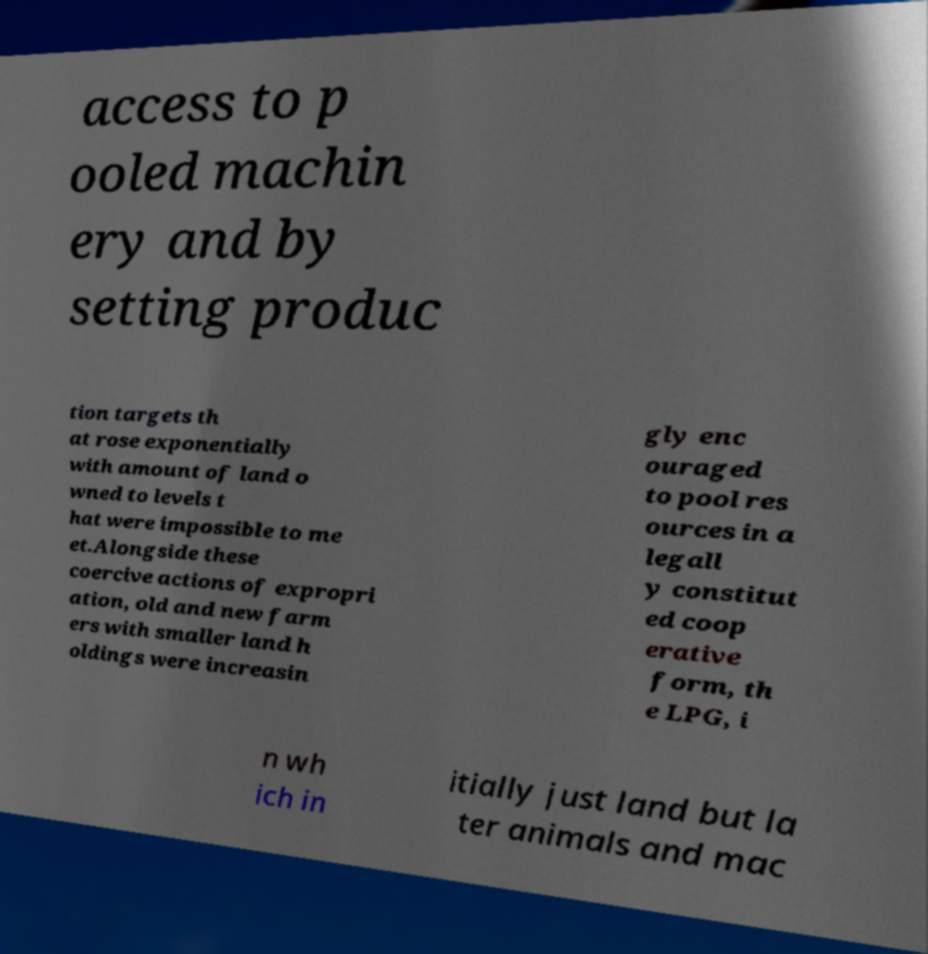There's text embedded in this image that I need extracted. Can you transcribe it verbatim? access to p ooled machin ery and by setting produc tion targets th at rose exponentially with amount of land o wned to levels t hat were impossible to me et.Alongside these coercive actions of expropri ation, old and new farm ers with smaller land h oldings were increasin gly enc ouraged to pool res ources in a legall y constitut ed coop erative form, th e LPG, i n wh ich in itially just land but la ter animals and mac 